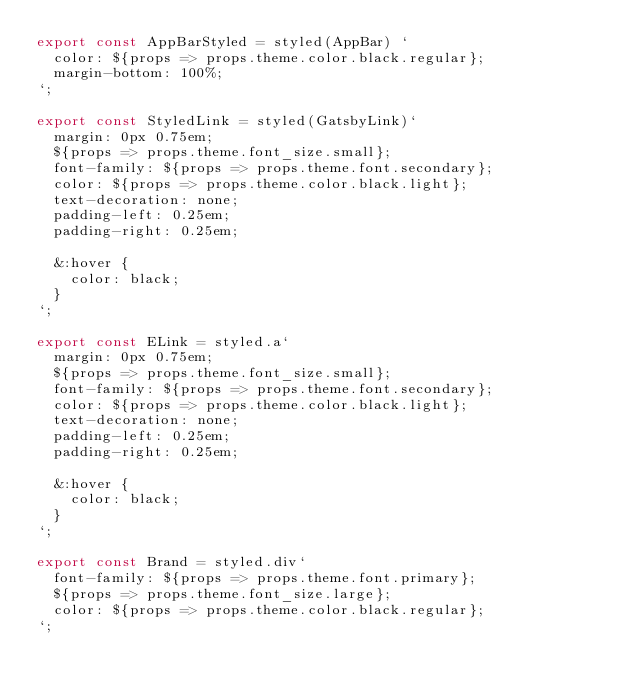Convert code to text. <code><loc_0><loc_0><loc_500><loc_500><_JavaScript_>export const AppBarStyled = styled(AppBar) `
  color: ${props => props.theme.color.black.regular};
  margin-bottom: 100%;
`;

export const StyledLink = styled(GatsbyLink)`
  margin: 0px 0.75em;
  ${props => props.theme.font_size.small};
  font-family: ${props => props.theme.font.secondary};
  color: ${props => props.theme.color.black.light};
  text-decoration: none;
  padding-left: 0.25em;
  padding-right: 0.25em;

  &:hover {
    color: black;
  }
`;

export const ELink = styled.a`
  margin: 0px 0.75em;
  ${props => props.theme.font_size.small};
  font-family: ${props => props.theme.font.secondary};
  color: ${props => props.theme.color.black.light};
  text-decoration: none;
  padding-left: 0.25em;
  padding-right: 0.25em;

  &:hover {
    color: black;
  }
`;

export const Brand = styled.div`
  font-family: ${props => props.theme.font.primary};
  ${props => props.theme.font_size.large};
  color: ${props => props.theme.color.black.regular};
`;
</code> 